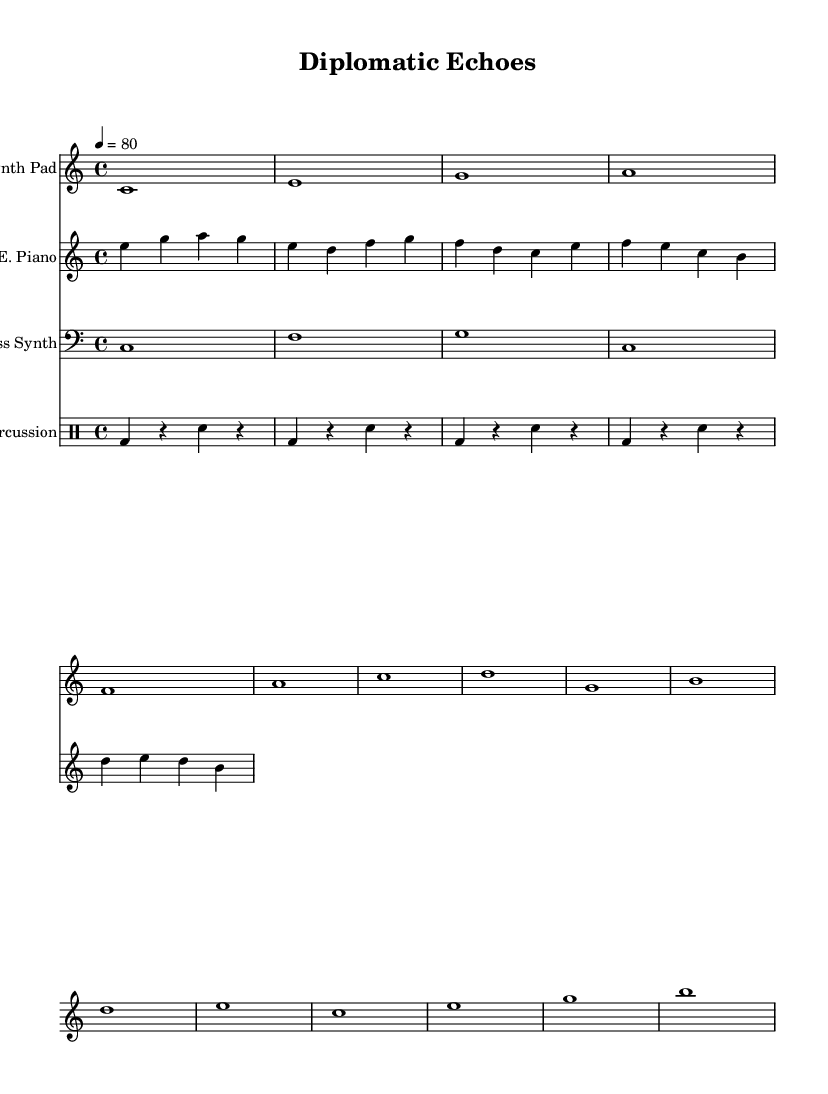What is the key signature of this music? The key signature is C major, which has no sharps or flats.
Answer: C major What is the time signature of this music? The time signature is indicated by the number at the beginning of each staff, which shows that there are four beats per measure.
Answer: 4/4 What is the tempo marking for this piece? The tempo marking indicates a speed of quaver beats, set to 80 beats per minute.
Answer: 80 How many staves are present in the score? Counting the number of distinct musical instruments listed, there are four staves: Synth Pad, E. Piano, Bass Synth, and Percussion.
Answer: 4 What type of synthesizer is indicated in the score? The section labeled 'Synth Pad' suggests the use of a synthesizer, specifically a pad type, known for its atmospheric soundscapes.
Answer: Synth Pad Which instrument plays the bass notes? The staff labeled 'Bass Synth' is designed to play the lower range notes, characteristic of a bass instrument.
Answer: Bass Synth What rhythmic pattern is used for the percussion? The drum notation indicates a consistent bass drum and snare pattern throughout the score, creating a steady rhythmic foundation.
Answer: Consistent bass drum and snare pattern 